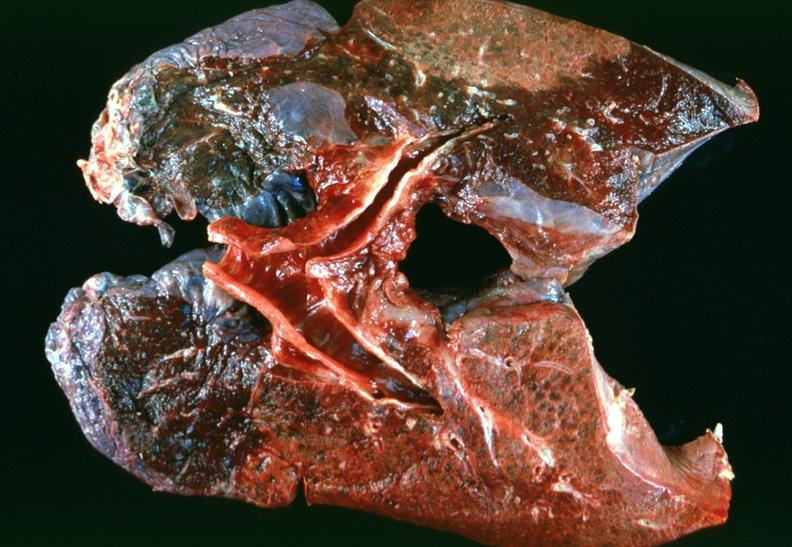what is present?
Answer the question using a single word or phrase. Respiratory 